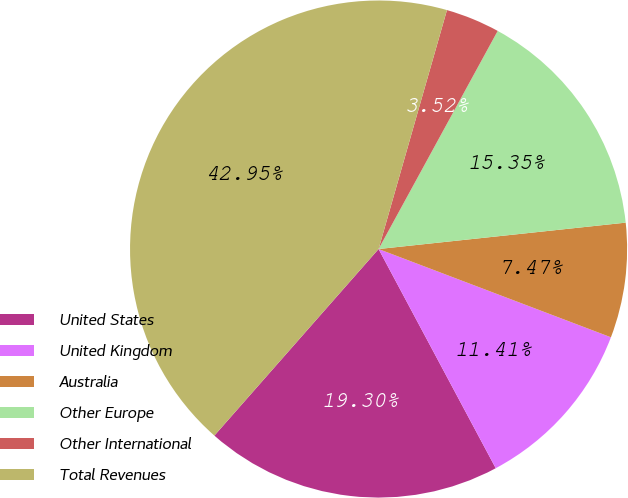Convert chart to OTSL. <chart><loc_0><loc_0><loc_500><loc_500><pie_chart><fcel>United States<fcel>United Kingdom<fcel>Australia<fcel>Other Europe<fcel>Other International<fcel>Total Revenues<nl><fcel>19.3%<fcel>11.41%<fcel>7.47%<fcel>15.35%<fcel>3.52%<fcel>42.95%<nl></chart> 